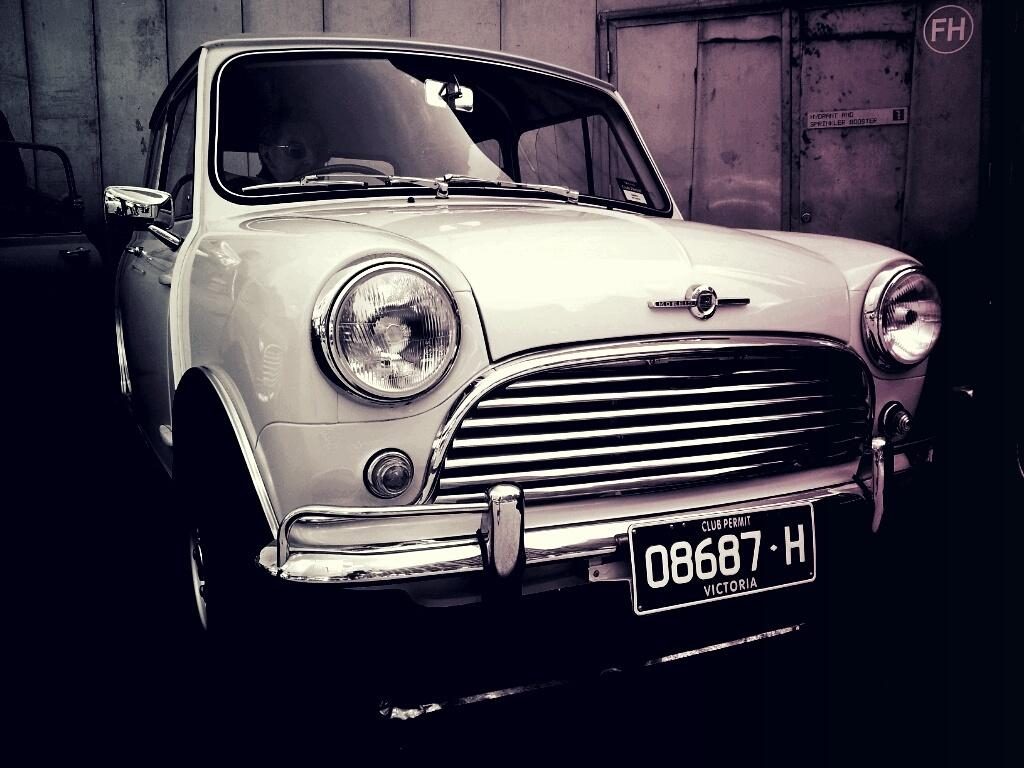<image>
Render a clear and concise summary of the photo. A classic automobile with the license tag 08687-H 